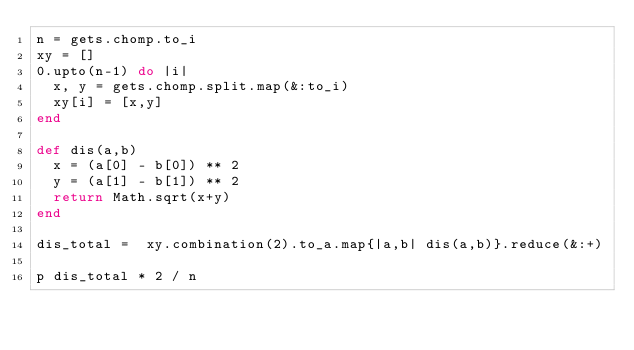Convert code to text. <code><loc_0><loc_0><loc_500><loc_500><_Ruby_>n = gets.chomp.to_i
xy = []
0.upto(n-1) do |i|
  x, y = gets.chomp.split.map(&:to_i)
  xy[i] = [x,y]
end

def dis(a,b)
  x = (a[0] - b[0]) ** 2
  y = (a[1] - b[1]) ** 2
  return Math.sqrt(x+y)
end

dis_total =  xy.combination(2).to_a.map{|a,b| dis(a,b)}.reduce(&:+)

p dis_total * 2 / n
</code> 